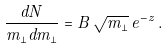<formula> <loc_0><loc_0><loc_500><loc_500>\frac { d N } { m _ { \perp } d m _ { \perp } } = B \, \sqrt { m _ { \perp } } \, e ^ { - z } \, .</formula> 